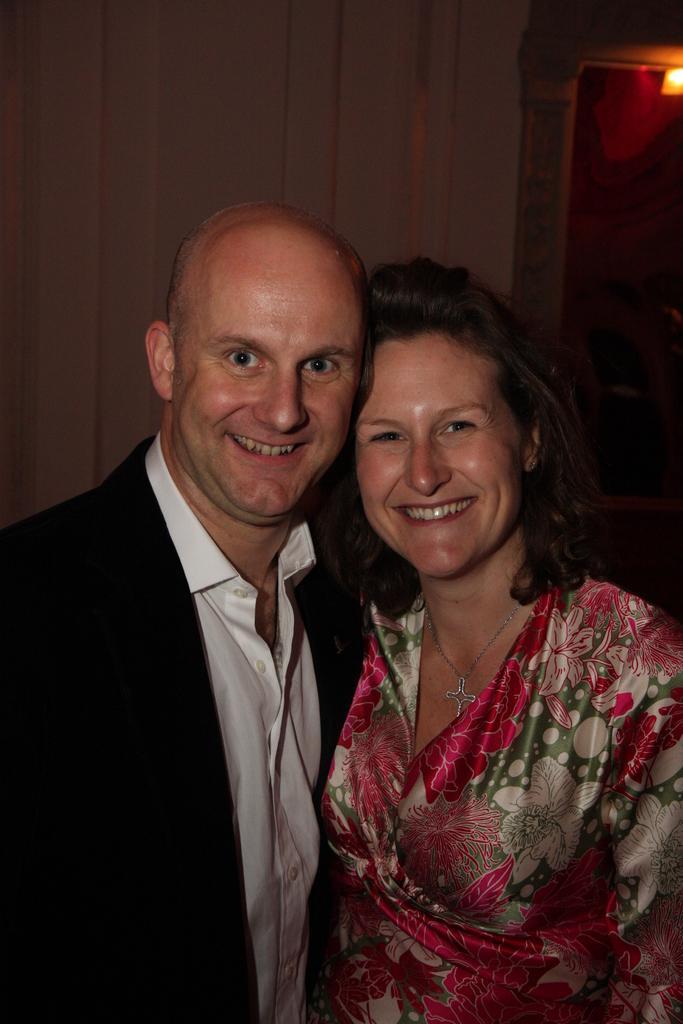In one or two sentences, can you explain what this image depicts? As we can see in the image in the front there are two people standing. The man on the left side is wearing black color jacket and the woman is wearing red color dress. Behind them there is a wall and on the right side background there is a light. 